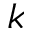Convert formula to latex. <formula><loc_0><loc_0><loc_500><loc_500>k</formula> 